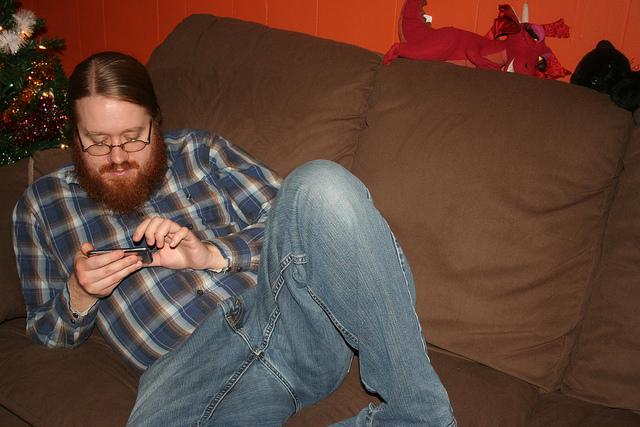What animal is the red stuffed animal?

Choices:
A) dragon
B) giraffe
C) teddy bear
D) kitty dragon 